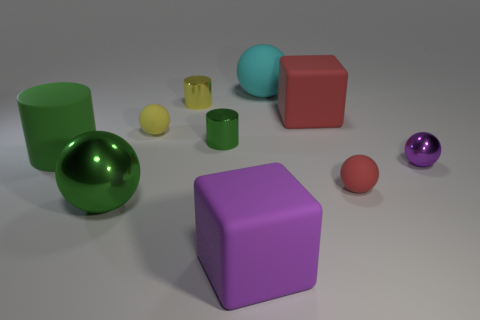There is a matte cylinder; is it the same color as the tiny cylinder on the right side of the yellow shiny cylinder?
Give a very brief answer. Yes. There is a big object that is both in front of the big red block and behind the big green sphere; what color is it?
Make the answer very short. Green. There is a large matte cube to the right of the big purple object; how many big cyan things are on the right side of it?
Keep it short and to the point. 0. Are there any other green things that have the same shape as the green matte object?
Offer a very short reply. Yes. Do the tiny metal object to the right of the small red matte object and the big matte object that is left of the tiny green cylinder have the same shape?
Give a very brief answer. No. What number of objects are large red objects or small purple cylinders?
Your answer should be very brief. 1. There is a yellow shiny thing that is the same shape as the green matte object; what size is it?
Give a very brief answer. Small. Are there more matte things behind the big green rubber object than brown metal things?
Your answer should be very brief. Yes. Is the material of the small green cylinder the same as the large cyan thing?
Your answer should be very brief. No. How many things are purple things that are in front of the small purple metal object or cylinders that are to the left of the green shiny cylinder?
Ensure brevity in your answer.  3. 